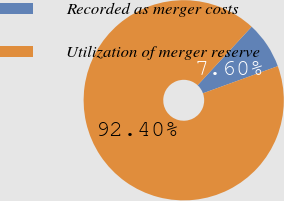<chart> <loc_0><loc_0><loc_500><loc_500><pie_chart><fcel>Recorded as merger costs<fcel>Utilization of merger reserve<nl><fcel>7.6%<fcel>92.4%<nl></chart> 